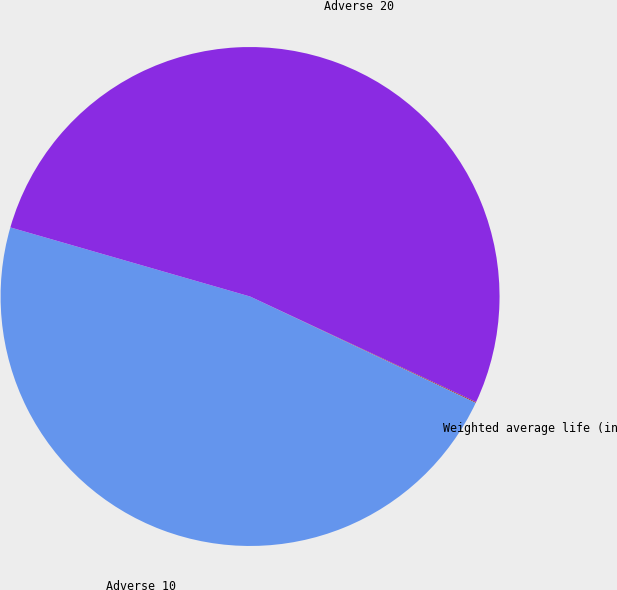Convert chart to OTSL. <chart><loc_0><loc_0><loc_500><loc_500><pie_chart><fcel>Weighted average life (in<fcel>Adverse 10<fcel>Adverse 20<nl><fcel>0.06%<fcel>47.46%<fcel>52.49%<nl></chart> 